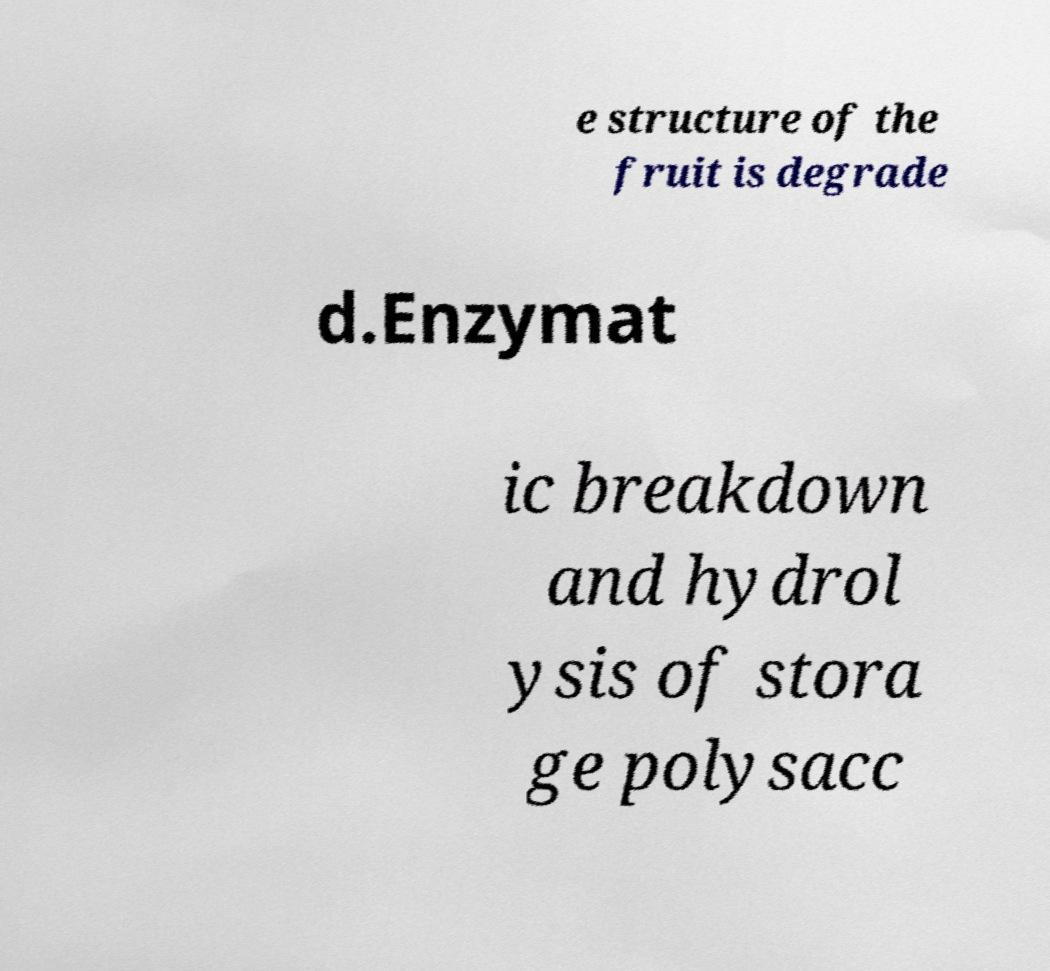For documentation purposes, I need the text within this image transcribed. Could you provide that? e structure of the fruit is degrade d.Enzymat ic breakdown and hydrol ysis of stora ge polysacc 